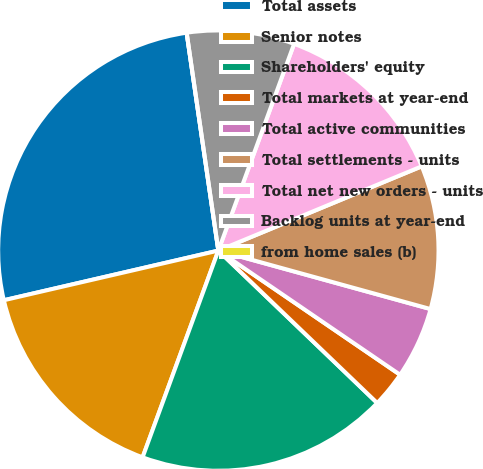Convert chart. <chart><loc_0><loc_0><loc_500><loc_500><pie_chart><fcel>Total assets<fcel>Senior notes<fcel>Shareholders' equity<fcel>Total markets at year-end<fcel>Total active communities<fcel>Total settlements - units<fcel>Total net new orders - units<fcel>Backlog units at year-end<fcel>from home sales (b)<nl><fcel>26.32%<fcel>15.79%<fcel>18.42%<fcel>2.63%<fcel>5.26%<fcel>10.53%<fcel>13.16%<fcel>7.89%<fcel>0.0%<nl></chart> 